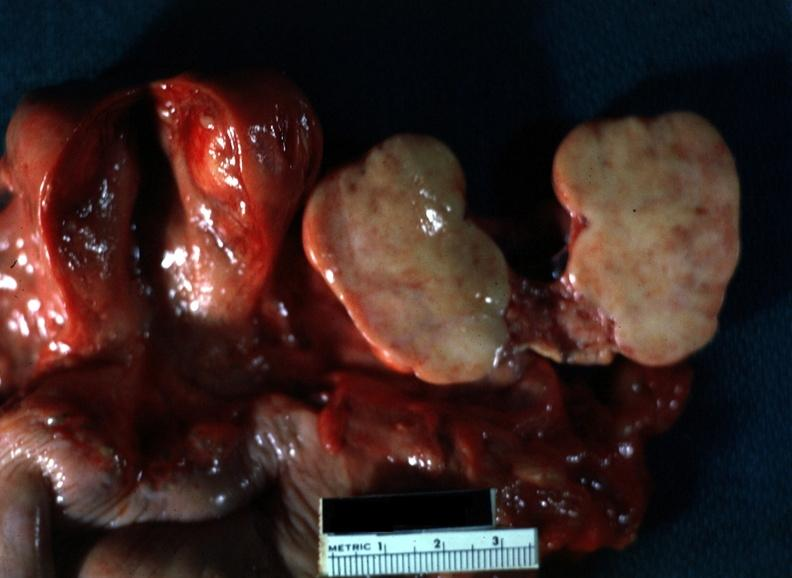what does this image show?
Answer the question using a single word or phrase. Close-up of lesion sliced open like a book typical for lesion with yellow foci evident view of all pelvic organ in slide 